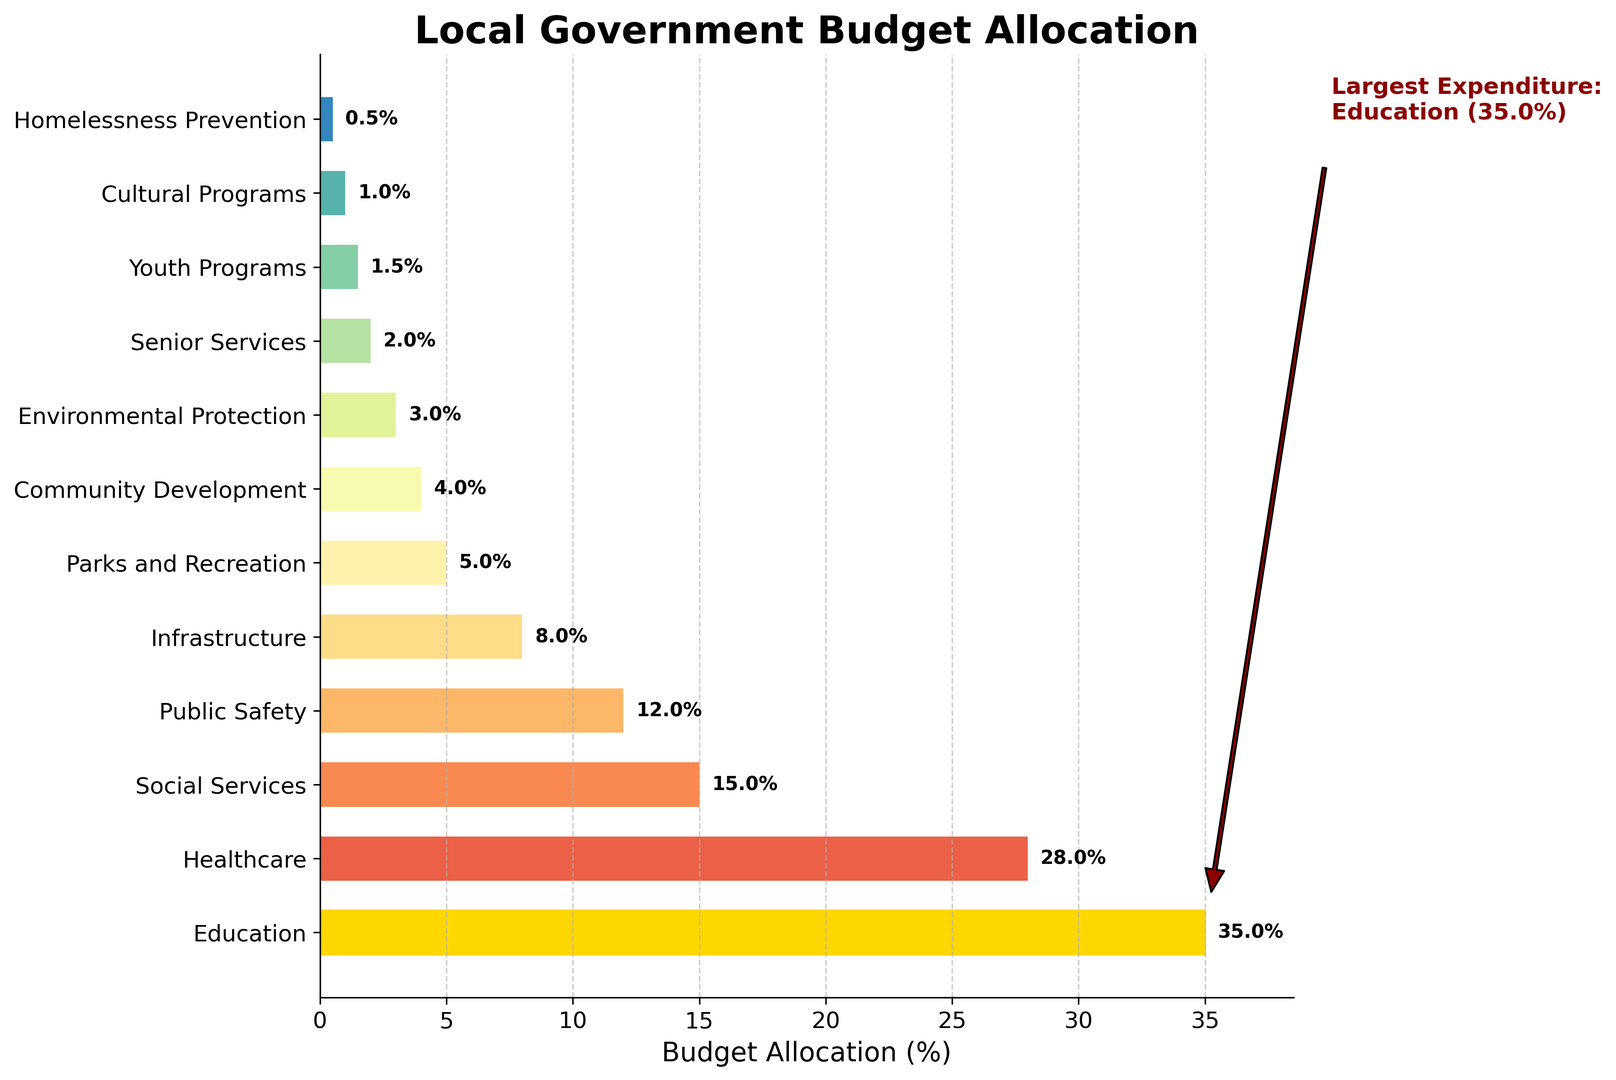What is the largest expenditure in the local government budget? The largest expenditure is annotated in the figure. It is highlighted in gold and is labelled with a text annotation.
Answer: Education Which two programs have similar budget allocations and what are their allocations? By examining the lengths of the bars and their positions, we see that Parks and Recreation (5%) and Community Development (4%) have similar allocations.
Answer: Parks and Recreation (5%), Community Development (4%) Compare the budget allocations between Healthcare and Public Safety. Which one is higher and by how much? Healthcare is represented by a longer bar compared to Public Safety. Healthcare is allocated 28% while Public Safety is allocated 12%. Therefore, Healthcare's allocation is higher by 16%.
Answer: Healthcare is higher by 16% What is the combined budget allocation for Senior Services and Youth Programs? The allocation for Senior Services is 2% and for Youth Programs is 1.5%. Adding these together, 2% + 1.5% = 3.5%.
Answer: 3.5% Which program has the smallest budget allocation and what is its value? The smallest allocation is represented by the shortest bar on the far right of the graph, which is Homelessness Prevention. The value is 0.5%.
Answer: Homelessness Prevention (0.5%) Identify the program that has the third-highest budget allocation. By looking at the lengths of the bars, the program with the third-highest allocation after Education (35%) and Healthcare (28%) is Social Services with 15%.
Answer: Social Services How much more is allocated to Infrastructure compared to Environmental Protection? The allocation for Infrastructure is 8% and for Environmental Protection is 3%. By subtracting the smaller allocation from the larger one, 8% - 3% = 5%.
Answer: 5% What is the total percentage allocation for Healthcare, Social Services, and Public Safety combined? The allocations are Healthcare (28%), Social Services (15%), and Public Safety (12%). Adding these together, 28% + 15% + 12% = 55%.
Answer: 55% What is the difference in budget allocation between the second and fifth-largest programs? The second-largest allocation is Healthcare (28%) and the fifth-largest is Infrastructure (8%). Subtracting the smaller from the larger, 28% - 8% = 20%.
Answer: 20% Which program allocated to cultural interests has a higher percentage: Cultural Programs or Parks and Recreation? Parks and Recreation has an allocation of 5%, whereas Cultural Programs have an allocation of 1%. Therefore, Parks and Recreation has a higher allocation.
Answer: Parks and Recreation 